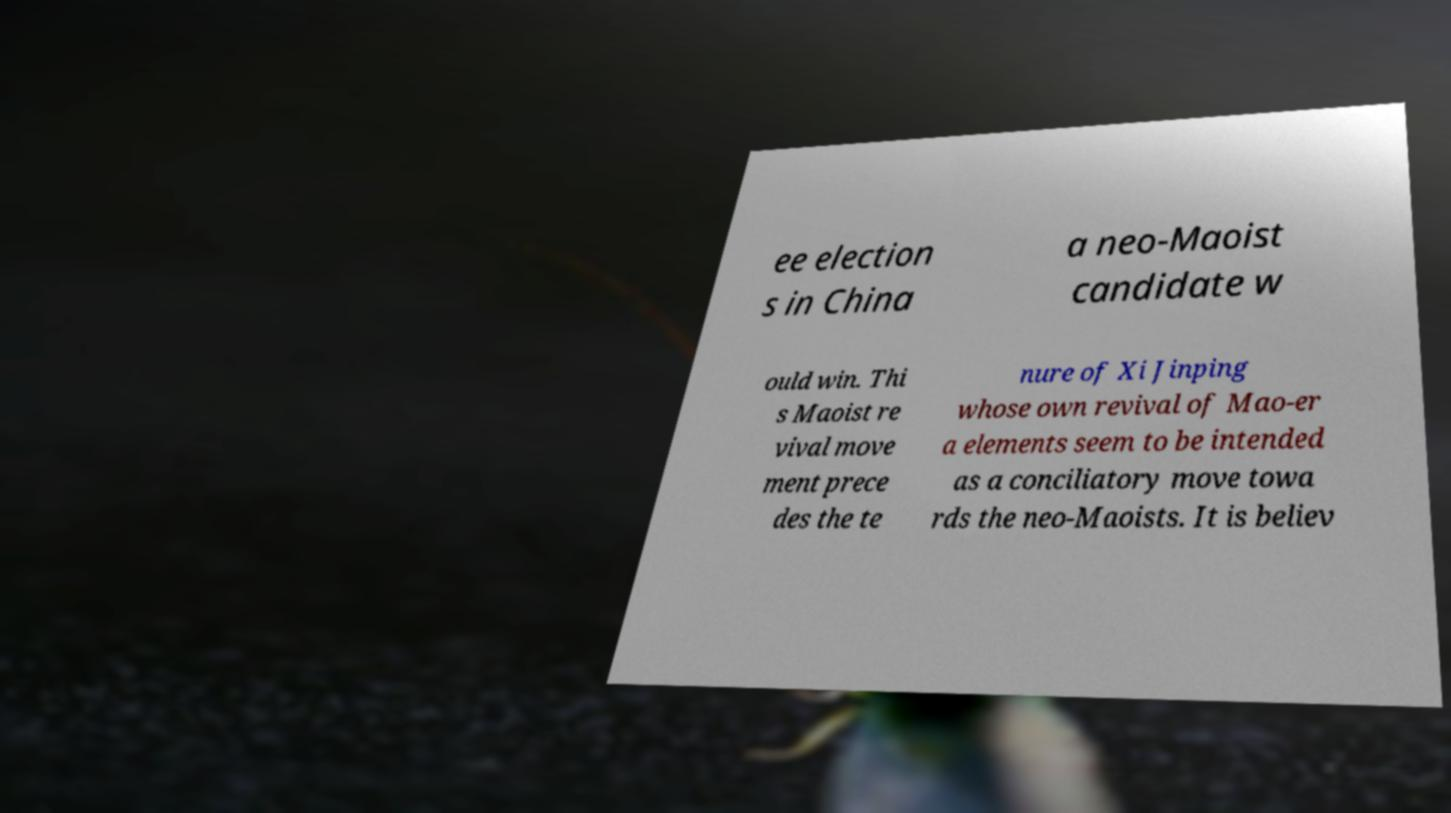Can you accurately transcribe the text from the provided image for me? ee election s in China a neo-Maoist candidate w ould win. Thi s Maoist re vival move ment prece des the te nure of Xi Jinping whose own revival of Mao-er a elements seem to be intended as a conciliatory move towa rds the neo-Maoists. It is believ 